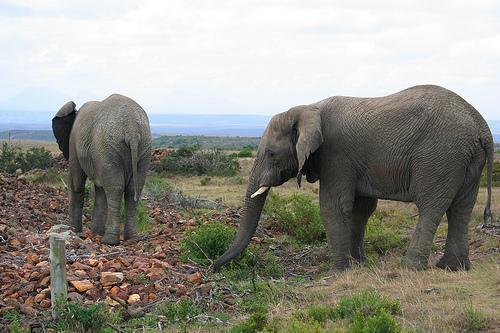How many elephants are there?
Give a very brief answer. 2. How many elephants are facing away from the camera?
Give a very brief answer. 1. 